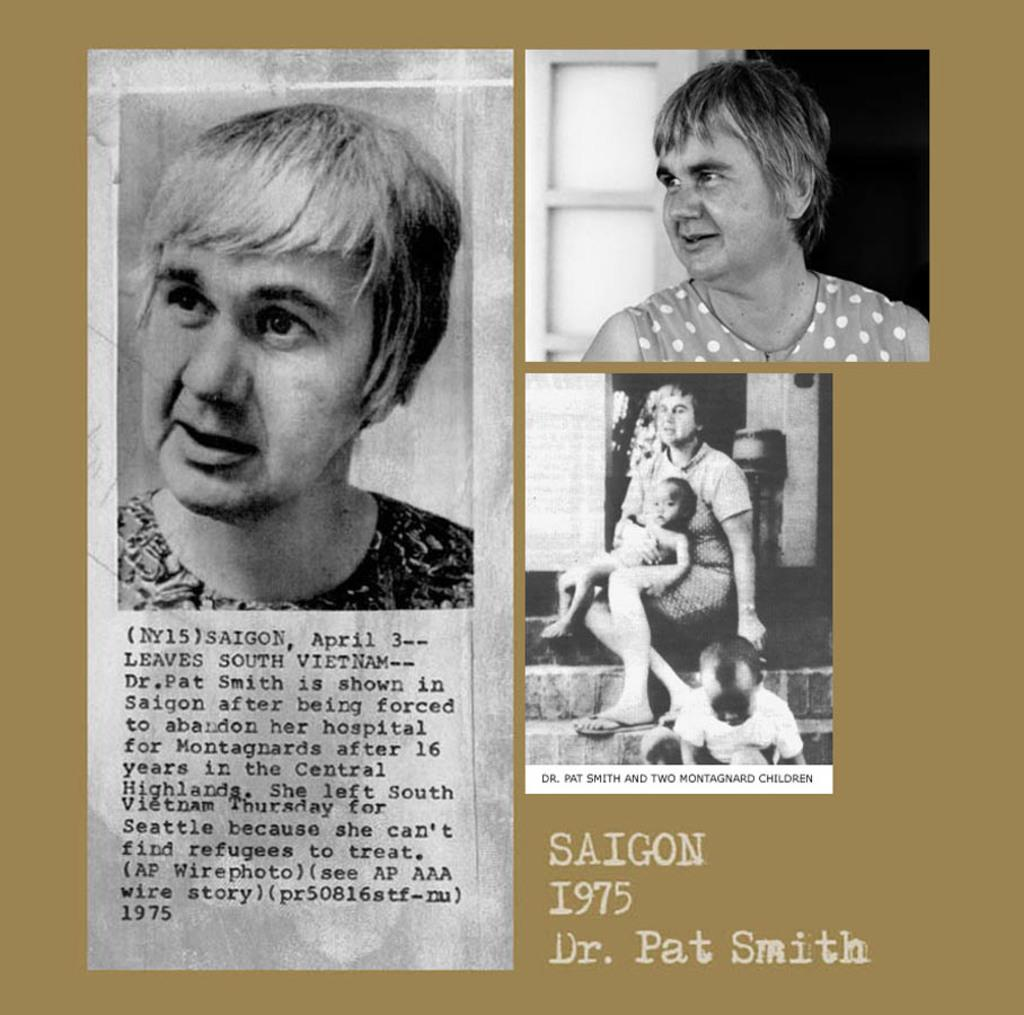How many images of a woman are present in the picture? There are three images of a woman in the picture. Are there any other people present in the images? Yes, in one of the images, there are two kids. Where can some text be found in the picture? The text is located on the left side of the picture. What type of silver tray is being used by the woman in the image? There is no silver tray present in the image. How much debt is the woman in the image trying to pay off? There is no information about debt in the image. 